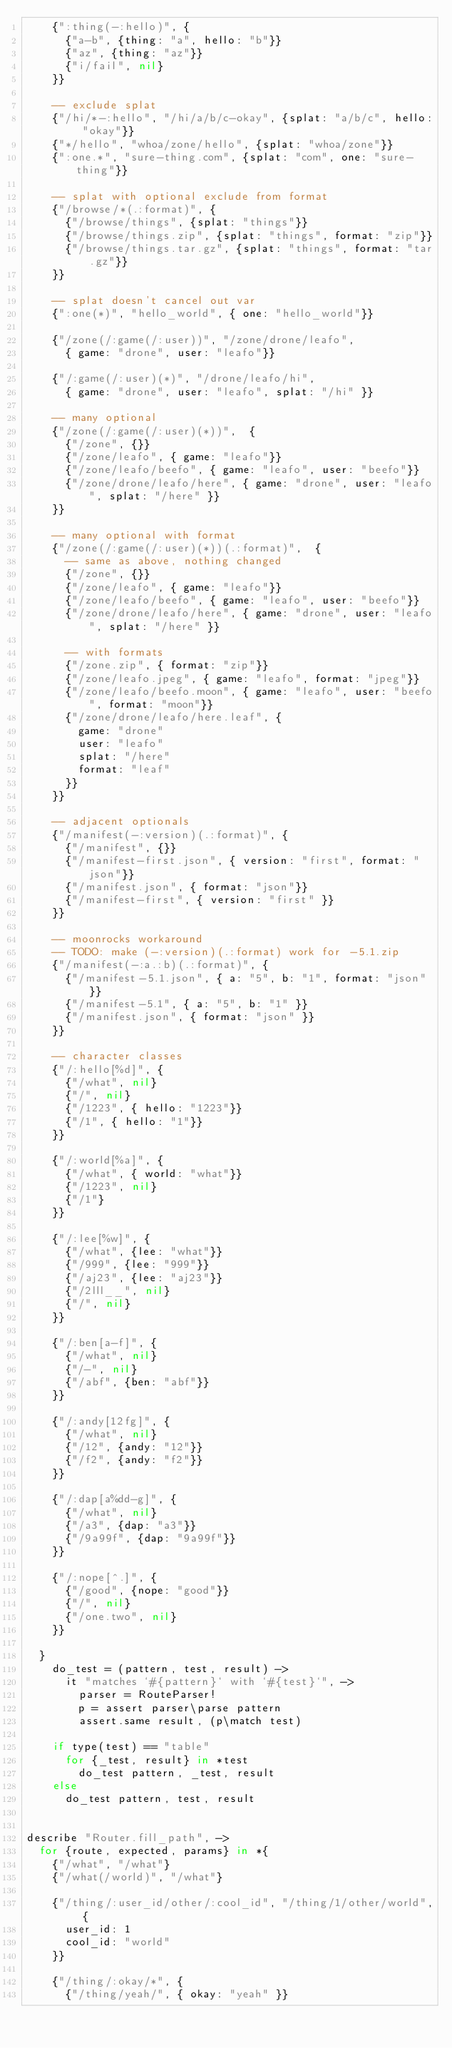Convert code to text. <code><loc_0><loc_0><loc_500><loc_500><_MoonScript_>    {":thing(-:hello)", {
      {"a-b", {thing: "a", hello: "b"}}
      {"az", {thing: "az"}}
      {"i/fail", nil}
    }}

    -- exclude splat
    {"/hi/*-:hello", "/hi/a/b/c-okay", {splat: "a/b/c", hello: "okay"}}
    {"*/hello", "whoa/zone/hello", {splat: "whoa/zone"}}
    {":one.*", "sure-thing.com", {splat: "com", one: "sure-thing"}}

    -- splat with optional exclude from format
    {"/browse/*(.:format)", {
      {"/browse/things", {splat: "things"}}
      {"/browse/things.zip", {splat: "things", format: "zip"}}
      {"/browse/things.tar.gz", {splat: "things", format: "tar.gz"}}
    }}

    -- splat doesn't cancel out var
    {":one(*)", "hello_world", { one: "hello_world"}}

    {"/zone(/:game(/:user))", "/zone/drone/leafo",
      { game: "drone", user: "leafo"}}

    {"/:game(/:user)(*)", "/drone/leafo/hi",
      { game: "drone", user: "leafo", splat: "/hi" }}

    -- many optional
    {"/zone(/:game(/:user)(*))",  {
      {"/zone", {}}
      {"/zone/leafo", { game: "leafo"}}
      {"/zone/leafo/beefo", { game: "leafo", user: "beefo"}}
      {"/zone/drone/leafo/here", { game: "drone", user: "leafo", splat: "/here" }}
    }}

    -- many optional with format
    {"/zone(/:game(/:user)(*))(.:format)",  {
      -- same as above, nothing changed
      {"/zone", {}}
      {"/zone/leafo", { game: "leafo"}}
      {"/zone/leafo/beefo", { game: "leafo", user: "beefo"}}
      {"/zone/drone/leafo/here", { game: "drone", user: "leafo", splat: "/here" }}

      -- with formats
      {"/zone.zip", { format: "zip"}}
      {"/zone/leafo.jpeg", { game: "leafo", format: "jpeg"}}
      {"/zone/leafo/beefo.moon", { game: "leafo", user: "beefo", format: "moon"}}
      {"/zone/drone/leafo/here.leaf", {
        game: "drone"
        user: "leafo"
        splat: "/here"
        format: "leaf"
      }}
    }}

    -- adjacent optionals
    {"/manifest(-:version)(.:format)", {
      {"/manifest", {}}
      {"/manifest-first.json", { version: "first", format: "json"}}
      {"/manifest.json", { format: "json"}}
      {"/manifest-first", { version: "first" }}
    }}

    -- moonrocks workaround
    -- TODO: make (-:version)(.:format) work for -5.1.zip
    {"/manifest(-:a.:b)(.:format)", {
      {"/manifest-5.1.json", { a: "5", b: "1", format: "json" }}
      {"/manifest-5.1", { a: "5", b: "1" }}
      {"/manifest.json", { format: "json" }}
    }}

    -- character classes
    {"/:hello[%d]", {
      {"/what", nil}
      {"/", nil}
      {"/1223", { hello: "1223"}}
      {"/1", { hello: "1"}}
    }}

    {"/:world[%a]", {
      {"/what", { world: "what"}}
      {"/1223", nil}
      {"/1"}
    }}

    {"/:lee[%w]", {
      {"/what", {lee: "what"}}
      {"/999", {lee: "999"}}
      {"/aj23", {lee: "aj23"}}
      {"/2lll__", nil}
      {"/", nil}
    }}

    {"/:ben[a-f]", {
      {"/what", nil}
      {"/-", nil}
      {"/abf", {ben: "abf"}}
    }}

    {"/:andy[12fg]", {
      {"/what", nil}
      {"/12", {andy: "12"}}
      {"/f2", {andy: "f2"}}
    }}

    {"/:dap[a%dd-g]", {
      {"/what", nil}
      {"/a3", {dap: "a3"}}
      {"/9a99f", {dap: "9a99f"}}
    }}

    {"/:nope[^.]", {
      {"/good", {nope: "good"}}
      {"/", nil}
      {"/one.two", nil}
    }}

  }
    do_test = (pattern, test, result) ->
      it "matches `#{pattern}` with `#{test}`", ->
        parser = RouteParser!
        p = assert parser\parse pattern
        assert.same result, (p\match test)

    if type(test) == "table"
      for {_test, result} in *test
        do_test pattern, _test, result
    else
      do_test pattern, test, result


describe "Router.fill_path", ->
  for {route, expected, params} in *{
    {"/what", "/what"}
    {"/what(/world)", "/what"}

    {"/thing/:user_id/other/:cool_id", "/thing/1/other/world", {
      user_id: 1
      cool_id: "world"
    }}

    {"/thing/:okay/*", {
      {"/thing/yeah/", { okay: "yeah" }}</code> 